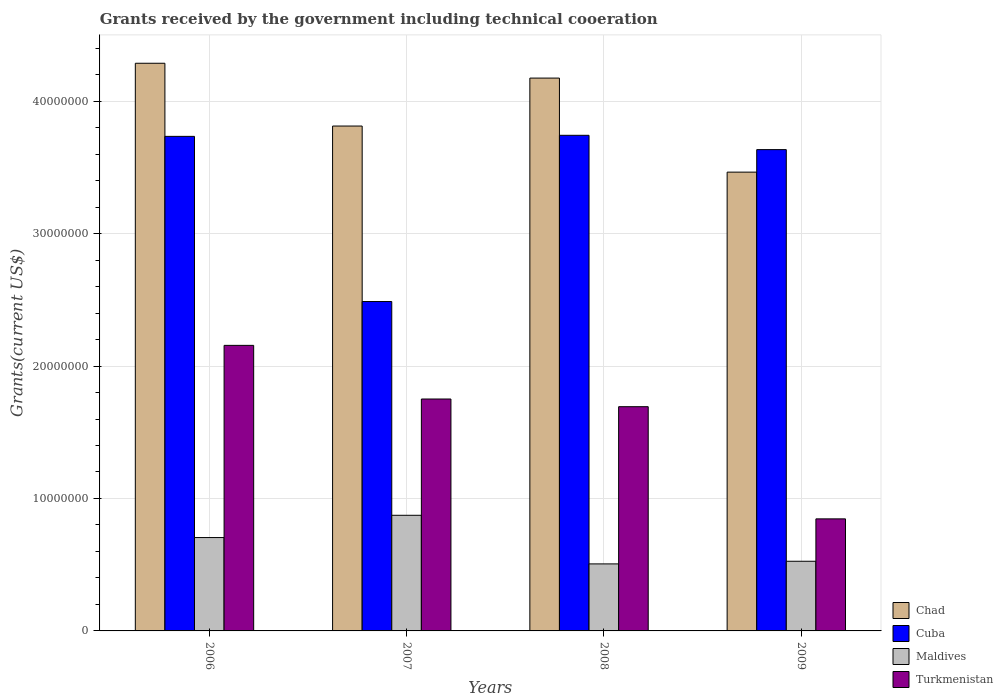How many different coloured bars are there?
Keep it short and to the point. 4. How many groups of bars are there?
Keep it short and to the point. 4. Are the number of bars per tick equal to the number of legend labels?
Keep it short and to the point. Yes. How many bars are there on the 1st tick from the left?
Give a very brief answer. 4. How many bars are there on the 4th tick from the right?
Provide a succinct answer. 4. What is the label of the 4th group of bars from the left?
Provide a short and direct response. 2009. What is the total grants received by the government in Maldives in 2008?
Provide a short and direct response. 5.06e+06. Across all years, what is the maximum total grants received by the government in Cuba?
Your answer should be compact. 3.74e+07. Across all years, what is the minimum total grants received by the government in Turkmenistan?
Your answer should be very brief. 8.46e+06. In which year was the total grants received by the government in Turkmenistan minimum?
Your answer should be very brief. 2009. What is the total total grants received by the government in Chad in the graph?
Make the answer very short. 1.57e+08. What is the difference between the total grants received by the government in Chad in 2006 and that in 2007?
Your answer should be very brief. 4.74e+06. What is the difference between the total grants received by the government in Chad in 2007 and the total grants received by the government in Turkmenistan in 2006?
Provide a short and direct response. 1.66e+07. What is the average total grants received by the government in Maldives per year?
Provide a succinct answer. 6.52e+06. In the year 2006, what is the difference between the total grants received by the government in Chad and total grants received by the government in Maldives?
Your response must be concise. 3.58e+07. In how many years, is the total grants received by the government in Chad greater than 18000000 US$?
Offer a terse response. 4. What is the ratio of the total grants received by the government in Chad in 2006 to that in 2008?
Keep it short and to the point. 1.03. Is the total grants received by the government in Turkmenistan in 2006 less than that in 2008?
Offer a very short reply. No. Is the difference between the total grants received by the government in Chad in 2006 and 2009 greater than the difference between the total grants received by the government in Maldives in 2006 and 2009?
Provide a short and direct response. Yes. What is the difference between the highest and the second highest total grants received by the government in Turkmenistan?
Offer a terse response. 4.05e+06. What is the difference between the highest and the lowest total grants received by the government in Maldives?
Make the answer very short. 3.67e+06. Is the sum of the total grants received by the government in Cuba in 2006 and 2007 greater than the maximum total grants received by the government in Maldives across all years?
Ensure brevity in your answer.  Yes. Is it the case that in every year, the sum of the total grants received by the government in Maldives and total grants received by the government in Turkmenistan is greater than the sum of total grants received by the government in Chad and total grants received by the government in Cuba?
Give a very brief answer. Yes. What does the 4th bar from the left in 2008 represents?
Offer a very short reply. Turkmenistan. What does the 4th bar from the right in 2008 represents?
Give a very brief answer. Chad. Are all the bars in the graph horizontal?
Keep it short and to the point. No. How many years are there in the graph?
Ensure brevity in your answer.  4. What is the difference between two consecutive major ticks on the Y-axis?
Offer a very short reply. 1.00e+07. Are the values on the major ticks of Y-axis written in scientific E-notation?
Your response must be concise. No. Where does the legend appear in the graph?
Your answer should be compact. Bottom right. What is the title of the graph?
Make the answer very short. Grants received by the government including technical cooeration. Does "Dominican Republic" appear as one of the legend labels in the graph?
Offer a very short reply. No. What is the label or title of the X-axis?
Keep it short and to the point. Years. What is the label or title of the Y-axis?
Ensure brevity in your answer.  Grants(current US$). What is the Grants(current US$) in Chad in 2006?
Make the answer very short. 4.29e+07. What is the Grants(current US$) of Cuba in 2006?
Ensure brevity in your answer.  3.73e+07. What is the Grants(current US$) in Maldives in 2006?
Ensure brevity in your answer.  7.05e+06. What is the Grants(current US$) in Turkmenistan in 2006?
Offer a terse response. 2.16e+07. What is the Grants(current US$) of Chad in 2007?
Give a very brief answer. 3.81e+07. What is the Grants(current US$) in Cuba in 2007?
Offer a terse response. 2.49e+07. What is the Grants(current US$) in Maldives in 2007?
Your response must be concise. 8.73e+06. What is the Grants(current US$) of Turkmenistan in 2007?
Provide a succinct answer. 1.75e+07. What is the Grants(current US$) of Chad in 2008?
Give a very brief answer. 4.17e+07. What is the Grants(current US$) of Cuba in 2008?
Keep it short and to the point. 3.74e+07. What is the Grants(current US$) in Maldives in 2008?
Offer a very short reply. 5.06e+06. What is the Grants(current US$) of Turkmenistan in 2008?
Your answer should be compact. 1.69e+07. What is the Grants(current US$) in Chad in 2009?
Offer a terse response. 3.46e+07. What is the Grants(current US$) of Cuba in 2009?
Ensure brevity in your answer.  3.63e+07. What is the Grants(current US$) in Maldives in 2009?
Make the answer very short. 5.26e+06. What is the Grants(current US$) in Turkmenistan in 2009?
Offer a very short reply. 8.46e+06. Across all years, what is the maximum Grants(current US$) in Chad?
Your answer should be very brief. 4.29e+07. Across all years, what is the maximum Grants(current US$) of Cuba?
Provide a short and direct response. 3.74e+07. Across all years, what is the maximum Grants(current US$) in Maldives?
Provide a short and direct response. 8.73e+06. Across all years, what is the maximum Grants(current US$) in Turkmenistan?
Your response must be concise. 2.16e+07. Across all years, what is the minimum Grants(current US$) of Chad?
Provide a short and direct response. 3.46e+07. Across all years, what is the minimum Grants(current US$) in Cuba?
Your answer should be very brief. 2.49e+07. Across all years, what is the minimum Grants(current US$) in Maldives?
Provide a short and direct response. 5.06e+06. Across all years, what is the minimum Grants(current US$) in Turkmenistan?
Your response must be concise. 8.46e+06. What is the total Grants(current US$) of Chad in the graph?
Ensure brevity in your answer.  1.57e+08. What is the total Grants(current US$) in Cuba in the graph?
Ensure brevity in your answer.  1.36e+08. What is the total Grants(current US$) in Maldives in the graph?
Keep it short and to the point. 2.61e+07. What is the total Grants(current US$) in Turkmenistan in the graph?
Offer a terse response. 6.45e+07. What is the difference between the Grants(current US$) in Chad in 2006 and that in 2007?
Ensure brevity in your answer.  4.74e+06. What is the difference between the Grants(current US$) in Cuba in 2006 and that in 2007?
Your answer should be very brief. 1.25e+07. What is the difference between the Grants(current US$) of Maldives in 2006 and that in 2007?
Offer a terse response. -1.68e+06. What is the difference between the Grants(current US$) in Turkmenistan in 2006 and that in 2007?
Make the answer very short. 4.05e+06. What is the difference between the Grants(current US$) of Chad in 2006 and that in 2008?
Ensure brevity in your answer.  1.12e+06. What is the difference between the Grants(current US$) in Maldives in 2006 and that in 2008?
Keep it short and to the point. 1.99e+06. What is the difference between the Grants(current US$) of Turkmenistan in 2006 and that in 2008?
Provide a short and direct response. 4.63e+06. What is the difference between the Grants(current US$) of Chad in 2006 and that in 2009?
Ensure brevity in your answer.  8.22e+06. What is the difference between the Grants(current US$) in Maldives in 2006 and that in 2009?
Your response must be concise. 1.79e+06. What is the difference between the Grants(current US$) in Turkmenistan in 2006 and that in 2009?
Provide a succinct answer. 1.31e+07. What is the difference between the Grants(current US$) in Chad in 2007 and that in 2008?
Your answer should be compact. -3.62e+06. What is the difference between the Grants(current US$) of Cuba in 2007 and that in 2008?
Offer a very short reply. -1.26e+07. What is the difference between the Grants(current US$) of Maldives in 2007 and that in 2008?
Offer a very short reply. 3.67e+06. What is the difference between the Grants(current US$) of Turkmenistan in 2007 and that in 2008?
Your answer should be compact. 5.80e+05. What is the difference between the Grants(current US$) of Chad in 2007 and that in 2009?
Give a very brief answer. 3.48e+06. What is the difference between the Grants(current US$) in Cuba in 2007 and that in 2009?
Make the answer very short. -1.15e+07. What is the difference between the Grants(current US$) of Maldives in 2007 and that in 2009?
Your answer should be compact. 3.47e+06. What is the difference between the Grants(current US$) of Turkmenistan in 2007 and that in 2009?
Offer a very short reply. 9.05e+06. What is the difference between the Grants(current US$) in Chad in 2008 and that in 2009?
Offer a very short reply. 7.10e+06. What is the difference between the Grants(current US$) of Cuba in 2008 and that in 2009?
Provide a succinct answer. 1.08e+06. What is the difference between the Grants(current US$) of Maldives in 2008 and that in 2009?
Ensure brevity in your answer.  -2.00e+05. What is the difference between the Grants(current US$) of Turkmenistan in 2008 and that in 2009?
Your answer should be very brief. 8.47e+06. What is the difference between the Grants(current US$) in Chad in 2006 and the Grants(current US$) in Cuba in 2007?
Make the answer very short. 1.80e+07. What is the difference between the Grants(current US$) in Chad in 2006 and the Grants(current US$) in Maldives in 2007?
Give a very brief answer. 3.41e+07. What is the difference between the Grants(current US$) of Chad in 2006 and the Grants(current US$) of Turkmenistan in 2007?
Provide a succinct answer. 2.54e+07. What is the difference between the Grants(current US$) of Cuba in 2006 and the Grants(current US$) of Maldives in 2007?
Your answer should be very brief. 2.86e+07. What is the difference between the Grants(current US$) of Cuba in 2006 and the Grants(current US$) of Turkmenistan in 2007?
Your response must be concise. 1.98e+07. What is the difference between the Grants(current US$) of Maldives in 2006 and the Grants(current US$) of Turkmenistan in 2007?
Keep it short and to the point. -1.05e+07. What is the difference between the Grants(current US$) in Chad in 2006 and the Grants(current US$) in Cuba in 2008?
Your answer should be very brief. 5.44e+06. What is the difference between the Grants(current US$) of Chad in 2006 and the Grants(current US$) of Maldives in 2008?
Provide a short and direct response. 3.78e+07. What is the difference between the Grants(current US$) of Chad in 2006 and the Grants(current US$) of Turkmenistan in 2008?
Keep it short and to the point. 2.59e+07. What is the difference between the Grants(current US$) of Cuba in 2006 and the Grants(current US$) of Maldives in 2008?
Offer a terse response. 3.23e+07. What is the difference between the Grants(current US$) in Cuba in 2006 and the Grants(current US$) in Turkmenistan in 2008?
Provide a succinct answer. 2.04e+07. What is the difference between the Grants(current US$) in Maldives in 2006 and the Grants(current US$) in Turkmenistan in 2008?
Offer a terse response. -9.88e+06. What is the difference between the Grants(current US$) of Chad in 2006 and the Grants(current US$) of Cuba in 2009?
Your response must be concise. 6.52e+06. What is the difference between the Grants(current US$) in Chad in 2006 and the Grants(current US$) in Maldives in 2009?
Ensure brevity in your answer.  3.76e+07. What is the difference between the Grants(current US$) of Chad in 2006 and the Grants(current US$) of Turkmenistan in 2009?
Provide a succinct answer. 3.44e+07. What is the difference between the Grants(current US$) in Cuba in 2006 and the Grants(current US$) in Maldives in 2009?
Your answer should be compact. 3.21e+07. What is the difference between the Grants(current US$) in Cuba in 2006 and the Grants(current US$) in Turkmenistan in 2009?
Your response must be concise. 2.89e+07. What is the difference between the Grants(current US$) of Maldives in 2006 and the Grants(current US$) of Turkmenistan in 2009?
Provide a short and direct response. -1.41e+06. What is the difference between the Grants(current US$) of Chad in 2007 and the Grants(current US$) of Cuba in 2008?
Keep it short and to the point. 7.00e+05. What is the difference between the Grants(current US$) in Chad in 2007 and the Grants(current US$) in Maldives in 2008?
Provide a short and direct response. 3.31e+07. What is the difference between the Grants(current US$) of Chad in 2007 and the Grants(current US$) of Turkmenistan in 2008?
Offer a terse response. 2.12e+07. What is the difference between the Grants(current US$) of Cuba in 2007 and the Grants(current US$) of Maldives in 2008?
Offer a very short reply. 1.98e+07. What is the difference between the Grants(current US$) in Cuba in 2007 and the Grants(current US$) in Turkmenistan in 2008?
Make the answer very short. 7.94e+06. What is the difference between the Grants(current US$) of Maldives in 2007 and the Grants(current US$) of Turkmenistan in 2008?
Make the answer very short. -8.20e+06. What is the difference between the Grants(current US$) in Chad in 2007 and the Grants(current US$) in Cuba in 2009?
Keep it short and to the point. 1.78e+06. What is the difference between the Grants(current US$) in Chad in 2007 and the Grants(current US$) in Maldives in 2009?
Give a very brief answer. 3.29e+07. What is the difference between the Grants(current US$) of Chad in 2007 and the Grants(current US$) of Turkmenistan in 2009?
Your answer should be compact. 2.97e+07. What is the difference between the Grants(current US$) in Cuba in 2007 and the Grants(current US$) in Maldives in 2009?
Your answer should be very brief. 1.96e+07. What is the difference between the Grants(current US$) of Cuba in 2007 and the Grants(current US$) of Turkmenistan in 2009?
Give a very brief answer. 1.64e+07. What is the difference between the Grants(current US$) in Maldives in 2007 and the Grants(current US$) in Turkmenistan in 2009?
Your answer should be compact. 2.70e+05. What is the difference between the Grants(current US$) of Chad in 2008 and the Grants(current US$) of Cuba in 2009?
Your response must be concise. 5.40e+06. What is the difference between the Grants(current US$) in Chad in 2008 and the Grants(current US$) in Maldives in 2009?
Ensure brevity in your answer.  3.65e+07. What is the difference between the Grants(current US$) in Chad in 2008 and the Grants(current US$) in Turkmenistan in 2009?
Your answer should be very brief. 3.33e+07. What is the difference between the Grants(current US$) in Cuba in 2008 and the Grants(current US$) in Maldives in 2009?
Provide a succinct answer. 3.22e+07. What is the difference between the Grants(current US$) of Cuba in 2008 and the Grants(current US$) of Turkmenistan in 2009?
Make the answer very short. 2.90e+07. What is the difference between the Grants(current US$) in Maldives in 2008 and the Grants(current US$) in Turkmenistan in 2009?
Your answer should be very brief. -3.40e+06. What is the average Grants(current US$) in Chad per year?
Make the answer very short. 3.93e+07. What is the average Grants(current US$) of Cuba per year?
Offer a terse response. 3.40e+07. What is the average Grants(current US$) of Maldives per year?
Your answer should be compact. 6.52e+06. What is the average Grants(current US$) in Turkmenistan per year?
Your answer should be compact. 1.61e+07. In the year 2006, what is the difference between the Grants(current US$) of Chad and Grants(current US$) of Cuba?
Provide a succinct answer. 5.52e+06. In the year 2006, what is the difference between the Grants(current US$) of Chad and Grants(current US$) of Maldives?
Your answer should be very brief. 3.58e+07. In the year 2006, what is the difference between the Grants(current US$) of Chad and Grants(current US$) of Turkmenistan?
Make the answer very short. 2.13e+07. In the year 2006, what is the difference between the Grants(current US$) in Cuba and Grants(current US$) in Maldives?
Ensure brevity in your answer.  3.03e+07. In the year 2006, what is the difference between the Grants(current US$) of Cuba and Grants(current US$) of Turkmenistan?
Ensure brevity in your answer.  1.58e+07. In the year 2006, what is the difference between the Grants(current US$) in Maldives and Grants(current US$) in Turkmenistan?
Your response must be concise. -1.45e+07. In the year 2007, what is the difference between the Grants(current US$) of Chad and Grants(current US$) of Cuba?
Your answer should be compact. 1.32e+07. In the year 2007, what is the difference between the Grants(current US$) of Chad and Grants(current US$) of Maldives?
Offer a very short reply. 2.94e+07. In the year 2007, what is the difference between the Grants(current US$) in Chad and Grants(current US$) in Turkmenistan?
Your answer should be compact. 2.06e+07. In the year 2007, what is the difference between the Grants(current US$) of Cuba and Grants(current US$) of Maldives?
Your answer should be very brief. 1.61e+07. In the year 2007, what is the difference between the Grants(current US$) of Cuba and Grants(current US$) of Turkmenistan?
Give a very brief answer. 7.36e+06. In the year 2007, what is the difference between the Grants(current US$) in Maldives and Grants(current US$) in Turkmenistan?
Give a very brief answer. -8.78e+06. In the year 2008, what is the difference between the Grants(current US$) in Chad and Grants(current US$) in Cuba?
Provide a short and direct response. 4.32e+06. In the year 2008, what is the difference between the Grants(current US$) of Chad and Grants(current US$) of Maldives?
Your response must be concise. 3.67e+07. In the year 2008, what is the difference between the Grants(current US$) of Chad and Grants(current US$) of Turkmenistan?
Offer a terse response. 2.48e+07. In the year 2008, what is the difference between the Grants(current US$) in Cuba and Grants(current US$) in Maldives?
Ensure brevity in your answer.  3.24e+07. In the year 2008, what is the difference between the Grants(current US$) of Cuba and Grants(current US$) of Turkmenistan?
Your answer should be very brief. 2.05e+07. In the year 2008, what is the difference between the Grants(current US$) in Maldives and Grants(current US$) in Turkmenistan?
Your response must be concise. -1.19e+07. In the year 2009, what is the difference between the Grants(current US$) of Chad and Grants(current US$) of Cuba?
Keep it short and to the point. -1.70e+06. In the year 2009, what is the difference between the Grants(current US$) of Chad and Grants(current US$) of Maldives?
Provide a succinct answer. 2.94e+07. In the year 2009, what is the difference between the Grants(current US$) in Chad and Grants(current US$) in Turkmenistan?
Your answer should be very brief. 2.62e+07. In the year 2009, what is the difference between the Grants(current US$) in Cuba and Grants(current US$) in Maldives?
Make the answer very short. 3.11e+07. In the year 2009, what is the difference between the Grants(current US$) of Cuba and Grants(current US$) of Turkmenistan?
Your response must be concise. 2.79e+07. In the year 2009, what is the difference between the Grants(current US$) in Maldives and Grants(current US$) in Turkmenistan?
Offer a very short reply. -3.20e+06. What is the ratio of the Grants(current US$) in Chad in 2006 to that in 2007?
Provide a succinct answer. 1.12. What is the ratio of the Grants(current US$) in Cuba in 2006 to that in 2007?
Provide a short and direct response. 1.5. What is the ratio of the Grants(current US$) in Maldives in 2006 to that in 2007?
Make the answer very short. 0.81. What is the ratio of the Grants(current US$) in Turkmenistan in 2006 to that in 2007?
Offer a very short reply. 1.23. What is the ratio of the Grants(current US$) in Chad in 2006 to that in 2008?
Offer a terse response. 1.03. What is the ratio of the Grants(current US$) in Cuba in 2006 to that in 2008?
Your response must be concise. 1. What is the ratio of the Grants(current US$) of Maldives in 2006 to that in 2008?
Keep it short and to the point. 1.39. What is the ratio of the Grants(current US$) of Turkmenistan in 2006 to that in 2008?
Keep it short and to the point. 1.27. What is the ratio of the Grants(current US$) in Chad in 2006 to that in 2009?
Provide a short and direct response. 1.24. What is the ratio of the Grants(current US$) of Cuba in 2006 to that in 2009?
Offer a very short reply. 1.03. What is the ratio of the Grants(current US$) in Maldives in 2006 to that in 2009?
Your answer should be compact. 1.34. What is the ratio of the Grants(current US$) in Turkmenistan in 2006 to that in 2009?
Provide a succinct answer. 2.55. What is the ratio of the Grants(current US$) of Chad in 2007 to that in 2008?
Keep it short and to the point. 0.91. What is the ratio of the Grants(current US$) in Cuba in 2007 to that in 2008?
Make the answer very short. 0.66. What is the ratio of the Grants(current US$) of Maldives in 2007 to that in 2008?
Keep it short and to the point. 1.73. What is the ratio of the Grants(current US$) in Turkmenistan in 2007 to that in 2008?
Provide a short and direct response. 1.03. What is the ratio of the Grants(current US$) in Chad in 2007 to that in 2009?
Offer a terse response. 1.1. What is the ratio of the Grants(current US$) in Cuba in 2007 to that in 2009?
Give a very brief answer. 0.68. What is the ratio of the Grants(current US$) in Maldives in 2007 to that in 2009?
Give a very brief answer. 1.66. What is the ratio of the Grants(current US$) in Turkmenistan in 2007 to that in 2009?
Provide a short and direct response. 2.07. What is the ratio of the Grants(current US$) of Chad in 2008 to that in 2009?
Provide a short and direct response. 1.21. What is the ratio of the Grants(current US$) in Cuba in 2008 to that in 2009?
Offer a very short reply. 1.03. What is the ratio of the Grants(current US$) of Maldives in 2008 to that in 2009?
Your answer should be very brief. 0.96. What is the ratio of the Grants(current US$) of Turkmenistan in 2008 to that in 2009?
Your response must be concise. 2. What is the difference between the highest and the second highest Grants(current US$) in Chad?
Your answer should be very brief. 1.12e+06. What is the difference between the highest and the second highest Grants(current US$) of Cuba?
Your answer should be very brief. 8.00e+04. What is the difference between the highest and the second highest Grants(current US$) of Maldives?
Provide a succinct answer. 1.68e+06. What is the difference between the highest and the second highest Grants(current US$) of Turkmenistan?
Provide a succinct answer. 4.05e+06. What is the difference between the highest and the lowest Grants(current US$) in Chad?
Make the answer very short. 8.22e+06. What is the difference between the highest and the lowest Grants(current US$) of Cuba?
Offer a very short reply. 1.26e+07. What is the difference between the highest and the lowest Grants(current US$) of Maldives?
Ensure brevity in your answer.  3.67e+06. What is the difference between the highest and the lowest Grants(current US$) in Turkmenistan?
Keep it short and to the point. 1.31e+07. 